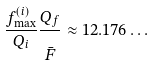<formula> <loc_0><loc_0><loc_500><loc_500>\frac { f ^ { ( i ) } _ { \max } } { Q _ { i } } \frac { Q _ { f } } { \strut \bar { F } } \approx 1 2 . 1 7 6 \dots</formula> 